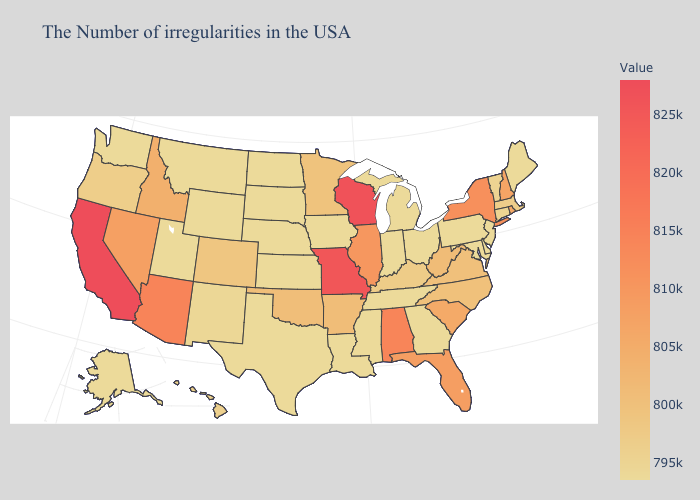Does Washington have the lowest value in the USA?
Answer briefly. Yes. Does Kentucky have the lowest value in the USA?
Give a very brief answer. No. Among the states that border Oregon , does Idaho have the highest value?
Write a very short answer. No. Among the states that border Mississippi , which have the highest value?
Be succinct. Alabama. Among the states that border Vermont , does New York have the lowest value?
Concise answer only. No. Among the states that border Rhode Island , does Massachusetts have the lowest value?
Quick response, please. No. Does South Carolina have the lowest value in the South?
Concise answer only. No. 